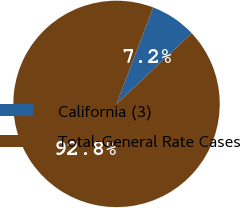Convert chart. <chart><loc_0><loc_0><loc_500><loc_500><pie_chart><fcel>California (3)<fcel>Total-General Rate Cases<nl><fcel>7.22%<fcel>92.78%<nl></chart> 